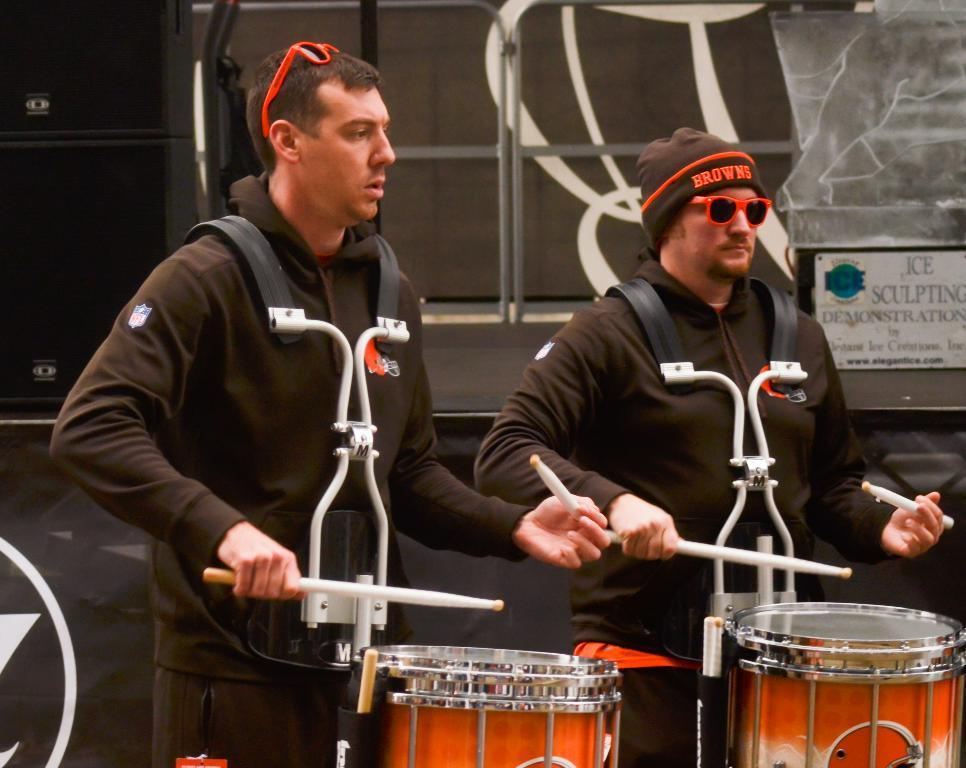How many people are in the image? There are two men in the image. What are the men wearing? Both men are wearing jackets. Does one of the men have any additional accessories? Yes, one of the men is wearing goggles. What are the men holding in their hands? The men are holding sticks in their hands. What are the sticks used for? The sticks are drums. What type of grape is being advertised in the image? There is no grape or advertisement present in the image. Can you tell me how the men are preparing for their flight in the image? There is no flight or preparation for a flight depicted in the image. 